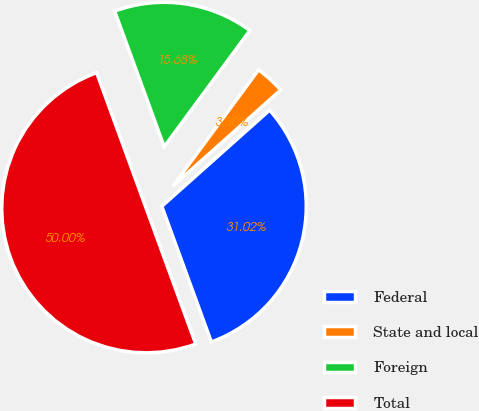Convert chart. <chart><loc_0><loc_0><loc_500><loc_500><pie_chart><fcel>Federal<fcel>State and local<fcel>Foreign<fcel>Total<nl><fcel>31.02%<fcel>3.3%<fcel>15.68%<fcel>50.0%<nl></chart> 